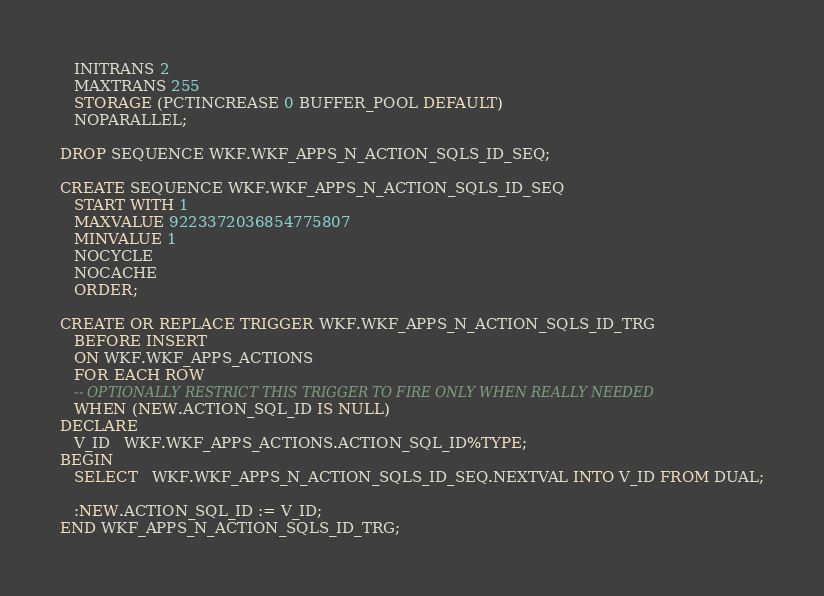Convert code to text. <code><loc_0><loc_0><loc_500><loc_500><_SQL_>   INITRANS 2
   MAXTRANS 255
   STORAGE (PCTINCREASE 0 BUFFER_POOL DEFAULT)
   NOPARALLEL;

DROP SEQUENCE WKF.WKF_APPS_N_ACTION_SQLS_ID_SEQ;

CREATE SEQUENCE WKF.WKF_APPS_N_ACTION_SQLS_ID_SEQ
   START WITH 1
   MAXVALUE 9223372036854775807
   MINVALUE 1
   NOCYCLE
   NOCACHE
   ORDER;

CREATE OR REPLACE TRIGGER WKF.WKF_APPS_N_ACTION_SQLS_ID_TRG
   BEFORE INSERT
   ON WKF.WKF_APPS_ACTIONS
   FOR EACH ROW
   -- OPTIONALLY RESTRICT THIS TRIGGER TO FIRE ONLY WHEN REALLY NEEDED
   WHEN (NEW.ACTION_SQL_ID IS NULL)
DECLARE
   V_ID   WKF.WKF_APPS_ACTIONS.ACTION_SQL_ID%TYPE;
BEGIN
   SELECT   WKF.WKF_APPS_N_ACTION_SQLS_ID_SEQ.NEXTVAL INTO V_ID FROM DUAL;

   :NEW.ACTION_SQL_ID := V_ID;
END WKF_APPS_N_ACTION_SQLS_ID_TRG;</code> 